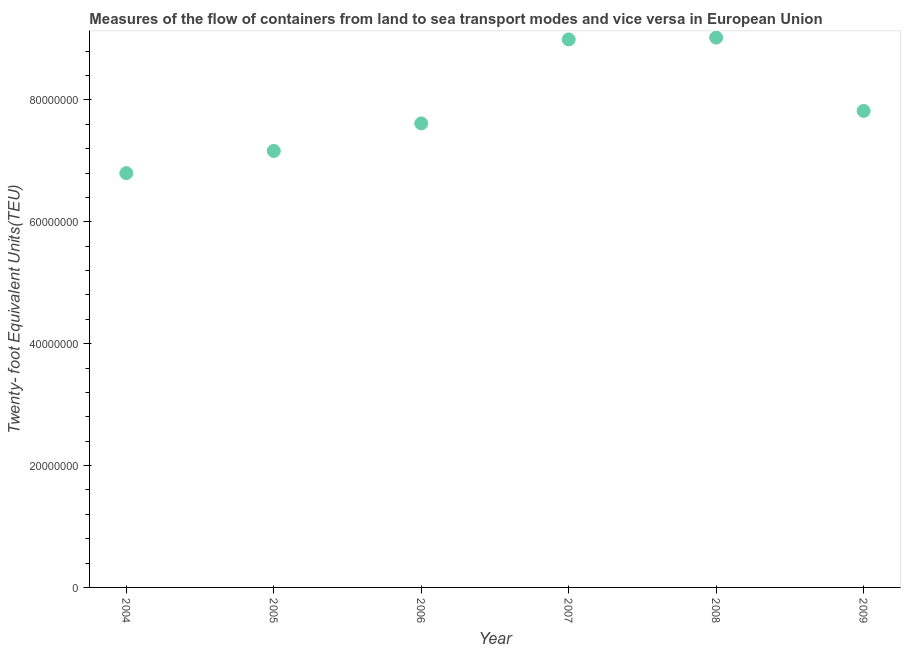What is the container port traffic in 2009?
Give a very brief answer. 7.82e+07. Across all years, what is the maximum container port traffic?
Your answer should be compact. 9.02e+07. Across all years, what is the minimum container port traffic?
Your answer should be compact. 6.80e+07. In which year was the container port traffic maximum?
Provide a short and direct response. 2008. What is the sum of the container port traffic?
Ensure brevity in your answer.  4.74e+08. What is the difference between the container port traffic in 2004 and 2005?
Provide a short and direct response. -3.64e+06. What is the average container port traffic per year?
Keep it short and to the point. 7.90e+07. What is the median container port traffic?
Your answer should be very brief. 7.72e+07. In how many years, is the container port traffic greater than 4000000 TEU?
Make the answer very short. 6. What is the ratio of the container port traffic in 2005 to that in 2008?
Offer a very short reply. 0.79. What is the difference between the highest and the second highest container port traffic?
Offer a terse response. 2.98e+05. What is the difference between the highest and the lowest container port traffic?
Offer a terse response. 2.22e+07. In how many years, is the container port traffic greater than the average container port traffic taken over all years?
Your response must be concise. 2. How many years are there in the graph?
Your response must be concise. 6. What is the title of the graph?
Ensure brevity in your answer.  Measures of the flow of containers from land to sea transport modes and vice versa in European Union. What is the label or title of the X-axis?
Keep it short and to the point. Year. What is the label or title of the Y-axis?
Make the answer very short. Twenty- foot Equivalent Units(TEU). What is the Twenty- foot Equivalent Units(TEU) in 2004?
Ensure brevity in your answer.  6.80e+07. What is the Twenty- foot Equivalent Units(TEU) in 2005?
Offer a terse response. 7.16e+07. What is the Twenty- foot Equivalent Units(TEU) in 2006?
Offer a very short reply. 7.61e+07. What is the Twenty- foot Equivalent Units(TEU) in 2007?
Keep it short and to the point. 8.99e+07. What is the Twenty- foot Equivalent Units(TEU) in 2008?
Offer a very short reply. 9.02e+07. What is the Twenty- foot Equivalent Units(TEU) in 2009?
Your answer should be compact. 7.82e+07. What is the difference between the Twenty- foot Equivalent Units(TEU) in 2004 and 2005?
Offer a very short reply. -3.64e+06. What is the difference between the Twenty- foot Equivalent Units(TEU) in 2004 and 2006?
Make the answer very short. -8.16e+06. What is the difference between the Twenty- foot Equivalent Units(TEU) in 2004 and 2007?
Give a very brief answer. -2.19e+07. What is the difference between the Twenty- foot Equivalent Units(TEU) in 2004 and 2008?
Your answer should be very brief. -2.22e+07. What is the difference between the Twenty- foot Equivalent Units(TEU) in 2004 and 2009?
Offer a terse response. -1.02e+07. What is the difference between the Twenty- foot Equivalent Units(TEU) in 2005 and 2006?
Offer a very short reply. -4.52e+06. What is the difference between the Twenty- foot Equivalent Units(TEU) in 2005 and 2007?
Keep it short and to the point. -1.83e+07. What is the difference between the Twenty- foot Equivalent Units(TEU) in 2005 and 2008?
Ensure brevity in your answer.  -1.86e+07. What is the difference between the Twenty- foot Equivalent Units(TEU) in 2005 and 2009?
Your answer should be compact. -6.57e+06. What is the difference between the Twenty- foot Equivalent Units(TEU) in 2006 and 2007?
Your response must be concise. -1.38e+07. What is the difference between the Twenty- foot Equivalent Units(TEU) in 2006 and 2008?
Provide a short and direct response. -1.41e+07. What is the difference between the Twenty- foot Equivalent Units(TEU) in 2006 and 2009?
Give a very brief answer. -2.05e+06. What is the difference between the Twenty- foot Equivalent Units(TEU) in 2007 and 2008?
Your answer should be very brief. -2.98e+05. What is the difference between the Twenty- foot Equivalent Units(TEU) in 2007 and 2009?
Keep it short and to the point. 1.17e+07. What is the difference between the Twenty- foot Equivalent Units(TEU) in 2008 and 2009?
Give a very brief answer. 1.20e+07. What is the ratio of the Twenty- foot Equivalent Units(TEU) in 2004 to that in 2005?
Your answer should be very brief. 0.95. What is the ratio of the Twenty- foot Equivalent Units(TEU) in 2004 to that in 2006?
Provide a succinct answer. 0.89. What is the ratio of the Twenty- foot Equivalent Units(TEU) in 2004 to that in 2007?
Offer a terse response. 0.76. What is the ratio of the Twenty- foot Equivalent Units(TEU) in 2004 to that in 2008?
Offer a terse response. 0.75. What is the ratio of the Twenty- foot Equivalent Units(TEU) in 2004 to that in 2009?
Your answer should be very brief. 0.87. What is the ratio of the Twenty- foot Equivalent Units(TEU) in 2005 to that in 2006?
Your answer should be compact. 0.94. What is the ratio of the Twenty- foot Equivalent Units(TEU) in 2005 to that in 2007?
Give a very brief answer. 0.8. What is the ratio of the Twenty- foot Equivalent Units(TEU) in 2005 to that in 2008?
Your answer should be compact. 0.79. What is the ratio of the Twenty- foot Equivalent Units(TEU) in 2005 to that in 2009?
Ensure brevity in your answer.  0.92. What is the ratio of the Twenty- foot Equivalent Units(TEU) in 2006 to that in 2007?
Your answer should be compact. 0.85. What is the ratio of the Twenty- foot Equivalent Units(TEU) in 2006 to that in 2008?
Offer a very short reply. 0.84. What is the ratio of the Twenty- foot Equivalent Units(TEU) in 2006 to that in 2009?
Your answer should be compact. 0.97. What is the ratio of the Twenty- foot Equivalent Units(TEU) in 2007 to that in 2008?
Provide a succinct answer. 1. What is the ratio of the Twenty- foot Equivalent Units(TEU) in 2007 to that in 2009?
Offer a terse response. 1.15. What is the ratio of the Twenty- foot Equivalent Units(TEU) in 2008 to that in 2009?
Provide a short and direct response. 1.15. 